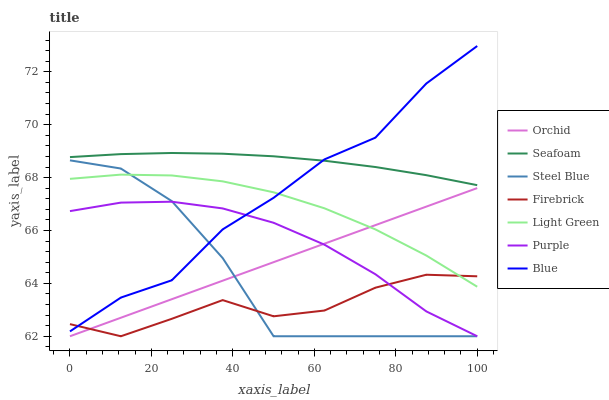Does Firebrick have the minimum area under the curve?
Answer yes or no. Yes. Does Seafoam have the maximum area under the curve?
Answer yes or no. Yes. Does Purple have the minimum area under the curve?
Answer yes or no. No. Does Purple have the maximum area under the curve?
Answer yes or no. No. Is Orchid the smoothest?
Answer yes or no. Yes. Is Steel Blue the roughest?
Answer yes or no. Yes. Is Purple the smoothest?
Answer yes or no. No. Is Purple the roughest?
Answer yes or no. No. Does Purple have the lowest value?
Answer yes or no. Yes. Does Seafoam have the lowest value?
Answer yes or no. No. Does Blue have the highest value?
Answer yes or no. Yes. Does Purple have the highest value?
Answer yes or no. No. Is Purple less than Seafoam?
Answer yes or no. Yes. Is Seafoam greater than Steel Blue?
Answer yes or no. Yes. Does Orchid intersect Steel Blue?
Answer yes or no. Yes. Is Orchid less than Steel Blue?
Answer yes or no. No. Is Orchid greater than Steel Blue?
Answer yes or no. No. Does Purple intersect Seafoam?
Answer yes or no. No. 